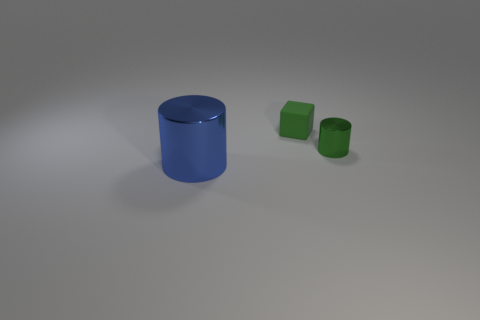Are there any other things that are the same size as the blue cylinder?
Provide a succinct answer. No. Are there any other things that have the same shape as the tiny green matte object?
Your response must be concise. No. Is the size of the blue cylinder the same as the green matte block?
Give a very brief answer. No. Is the color of the big metal thing the same as the cylinder to the right of the matte cube?
Keep it short and to the point. No. The big thing that is the same material as the tiny cylinder is what shape?
Ensure brevity in your answer.  Cylinder. There is a small rubber object behind the large metallic cylinder; is it the same shape as the small green metallic object?
Ensure brevity in your answer.  No. There is a metallic thing that is behind the cylinder in front of the green metallic object; what size is it?
Keep it short and to the point. Small. There is a small object that is made of the same material as the blue cylinder; what color is it?
Offer a very short reply. Green. What number of yellow metal cubes have the same size as the green matte block?
Make the answer very short. 0. How many blue things are either things or small things?
Your answer should be very brief. 1. 